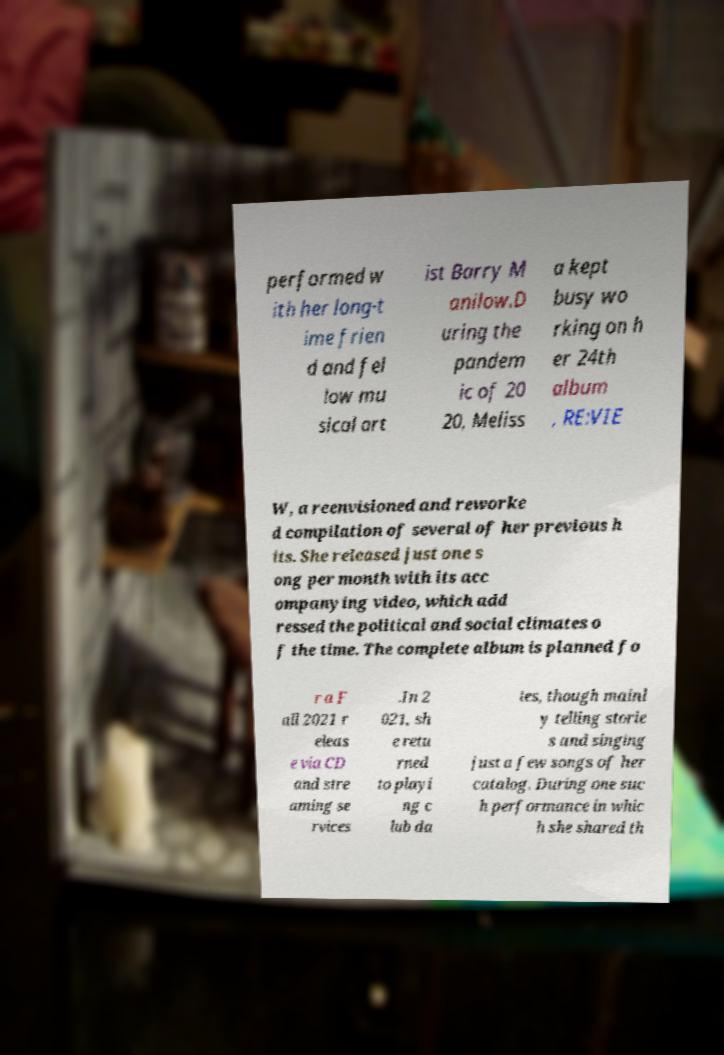I need the written content from this picture converted into text. Can you do that? performed w ith her long-t ime frien d and fel low mu sical art ist Barry M anilow.D uring the pandem ic of 20 20, Meliss a kept busy wo rking on h er 24th album , RE:VIE W, a reenvisioned and reworke d compilation of several of her previous h its. She released just one s ong per month with its acc ompanying video, which add ressed the political and social climates o f the time. The complete album is planned fo r a F all 2021 r eleas e via CD and stre aming se rvices .In 2 021, sh e retu rned to playi ng c lub da tes, though mainl y telling storie s and singing just a few songs of her catalog. During one suc h performance in whic h she shared th 